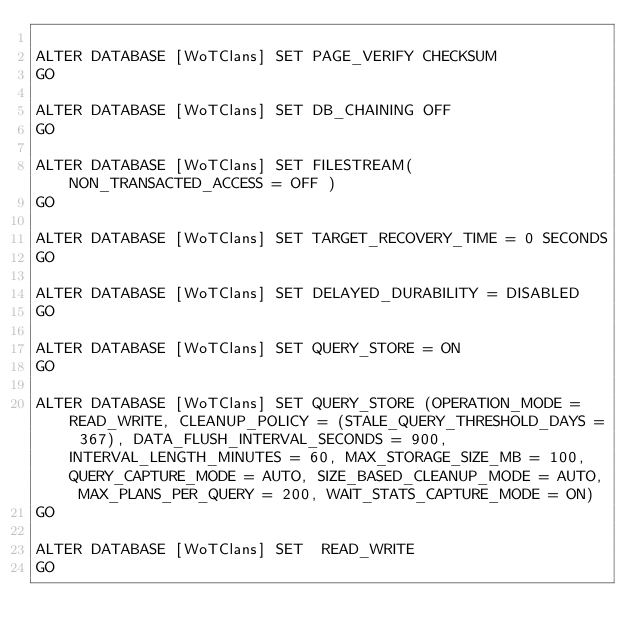<code> <loc_0><loc_0><loc_500><loc_500><_SQL_>
ALTER DATABASE [WoTClans] SET PAGE_VERIFY CHECKSUM  
GO

ALTER DATABASE [WoTClans] SET DB_CHAINING OFF 
GO

ALTER DATABASE [WoTClans] SET FILESTREAM( NON_TRANSACTED_ACCESS = OFF ) 
GO

ALTER DATABASE [WoTClans] SET TARGET_RECOVERY_TIME = 0 SECONDS 
GO

ALTER DATABASE [WoTClans] SET DELAYED_DURABILITY = DISABLED 
GO

ALTER DATABASE [WoTClans] SET QUERY_STORE = ON
GO

ALTER DATABASE [WoTClans] SET QUERY_STORE (OPERATION_MODE = READ_WRITE, CLEANUP_POLICY = (STALE_QUERY_THRESHOLD_DAYS = 367), DATA_FLUSH_INTERVAL_SECONDS = 900, INTERVAL_LENGTH_MINUTES = 60, MAX_STORAGE_SIZE_MB = 100, QUERY_CAPTURE_MODE = AUTO, SIZE_BASED_CLEANUP_MODE = AUTO, MAX_PLANS_PER_QUERY = 200, WAIT_STATS_CAPTURE_MODE = ON)
GO

ALTER DATABASE [WoTClans] SET  READ_WRITE 
GO

</code> 